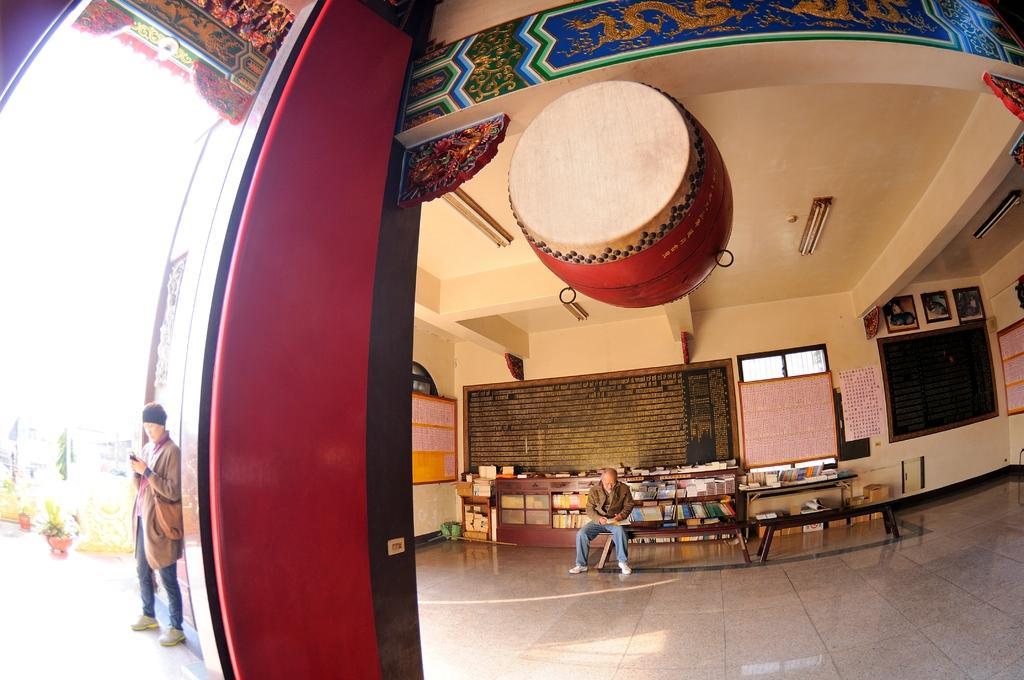In one or two sentences, can you explain what this image depicts? This picture shows a man standing hand holding a mobile in his hand and we see other man seated on the bench and we see few books on his back 